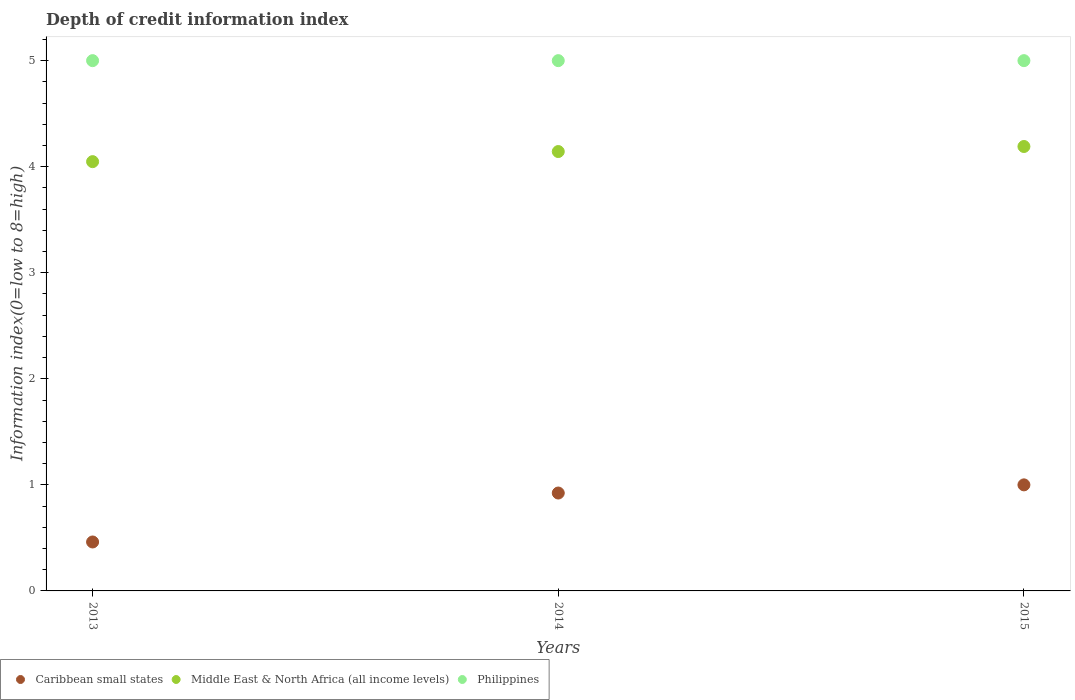Is the number of dotlines equal to the number of legend labels?
Keep it short and to the point. Yes. What is the information index in Philippines in 2014?
Provide a succinct answer. 5. Across all years, what is the maximum information index in Caribbean small states?
Provide a succinct answer. 1. Across all years, what is the minimum information index in Middle East & North Africa (all income levels)?
Ensure brevity in your answer.  4.05. In which year was the information index in Middle East & North Africa (all income levels) maximum?
Provide a short and direct response. 2015. In which year was the information index in Philippines minimum?
Offer a very short reply. 2013. What is the total information index in Middle East & North Africa (all income levels) in the graph?
Provide a short and direct response. 12.38. What is the difference between the information index in Philippines in 2013 and the information index in Middle East & North Africa (all income levels) in 2014?
Offer a very short reply. 0.86. What is the average information index in Middle East & North Africa (all income levels) per year?
Offer a terse response. 4.13. In the year 2014, what is the difference between the information index in Philippines and information index in Caribbean small states?
Give a very brief answer. 4.08. What is the ratio of the information index in Caribbean small states in 2014 to that in 2015?
Offer a very short reply. 0.92. What is the difference between the highest and the second highest information index in Caribbean small states?
Your answer should be very brief. 0.08. What is the difference between the highest and the lowest information index in Middle East & North Africa (all income levels)?
Offer a very short reply. 0.14. In how many years, is the information index in Caribbean small states greater than the average information index in Caribbean small states taken over all years?
Make the answer very short. 2. Is it the case that in every year, the sum of the information index in Philippines and information index in Middle East & North Africa (all income levels)  is greater than the information index in Caribbean small states?
Provide a short and direct response. Yes. What is the difference between two consecutive major ticks on the Y-axis?
Offer a very short reply. 1. Are the values on the major ticks of Y-axis written in scientific E-notation?
Make the answer very short. No. Does the graph contain any zero values?
Your response must be concise. No. Does the graph contain grids?
Offer a terse response. No. What is the title of the graph?
Your answer should be very brief. Depth of credit information index. Does "Cayman Islands" appear as one of the legend labels in the graph?
Your response must be concise. No. What is the label or title of the Y-axis?
Make the answer very short. Information index(0=low to 8=high). What is the Information index(0=low to 8=high) of Caribbean small states in 2013?
Provide a short and direct response. 0.46. What is the Information index(0=low to 8=high) of Middle East & North Africa (all income levels) in 2013?
Ensure brevity in your answer.  4.05. What is the Information index(0=low to 8=high) of Philippines in 2013?
Your response must be concise. 5. What is the Information index(0=low to 8=high) of Caribbean small states in 2014?
Your response must be concise. 0.92. What is the Information index(0=low to 8=high) in Middle East & North Africa (all income levels) in 2014?
Give a very brief answer. 4.14. What is the Information index(0=low to 8=high) in Philippines in 2014?
Your answer should be compact. 5. What is the Information index(0=low to 8=high) in Middle East & North Africa (all income levels) in 2015?
Your response must be concise. 4.19. Across all years, what is the maximum Information index(0=low to 8=high) of Middle East & North Africa (all income levels)?
Your answer should be compact. 4.19. Across all years, what is the minimum Information index(0=low to 8=high) in Caribbean small states?
Provide a short and direct response. 0.46. Across all years, what is the minimum Information index(0=low to 8=high) in Middle East & North Africa (all income levels)?
Your answer should be compact. 4.05. What is the total Information index(0=low to 8=high) in Caribbean small states in the graph?
Keep it short and to the point. 2.38. What is the total Information index(0=low to 8=high) in Middle East & North Africa (all income levels) in the graph?
Keep it short and to the point. 12.38. What is the total Information index(0=low to 8=high) of Philippines in the graph?
Provide a succinct answer. 15. What is the difference between the Information index(0=low to 8=high) of Caribbean small states in 2013 and that in 2014?
Keep it short and to the point. -0.46. What is the difference between the Information index(0=low to 8=high) in Middle East & North Africa (all income levels) in 2013 and that in 2014?
Give a very brief answer. -0.1. What is the difference between the Information index(0=low to 8=high) of Philippines in 2013 and that in 2014?
Ensure brevity in your answer.  0. What is the difference between the Information index(0=low to 8=high) of Caribbean small states in 2013 and that in 2015?
Your answer should be very brief. -0.54. What is the difference between the Information index(0=low to 8=high) in Middle East & North Africa (all income levels) in 2013 and that in 2015?
Provide a succinct answer. -0.14. What is the difference between the Information index(0=low to 8=high) of Caribbean small states in 2014 and that in 2015?
Offer a terse response. -0.08. What is the difference between the Information index(0=low to 8=high) of Middle East & North Africa (all income levels) in 2014 and that in 2015?
Offer a terse response. -0.05. What is the difference between the Information index(0=low to 8=high) of Philippines in 2014 and that in 2015?
Offer a very short reply. 0. What is the difference between the Information index(0=low to 8=high) of Caribbean small states in 2013 and the Information index(0=low to 8=high) of Middle East & North Africa (all income levels) in 2014?
Provide a short and direct response. -3.68. What is the difference between the Information index(0=low to 8=high) of Caribbean small states in 2013 and the Information index(0=low to 8=high) of Philippines in 2014?
Offer a very short reply. -4.54. What is the difference between the Information index(0=low to 8=high) of Middle East & North Africa (all income levels) in 2013 and the Information index(0=low to 8=high) of Philippines in 2014?
Provide a succinct answer. -0.95. What is the difference between the Information index(0=low to 8=high) in Caribbean small states in 2013 and the Information index(0=low to 8=high) in Middle East & North Africa (all income levels) in 2015?
Your answer should be very brief. -3.73. What is the difference between the Information index(0=low to 8=high) of Caribbean small states in 2013 and the Information index(0=low to 8=high) of Philippines in 2015?
Offer a terse response. -4.54. What is the difference between the Information index(0=low to 8=high) in Middle East & North Africa (all income levels) in 2013 and the Information index(0=low to 8=high) in Philippines in 2015?
Ensure brevity in your answer.  -0.95. What is the difference between the Information index(0=low to 8=high) of Caribbean small states in 2014 and the Information index(0=low to 8=high) of Middle East & North Africa (all income levels) in 2015?
Your answer should be very brief. -3.27. What is the difference between the Information index(0=low to 8=high) in Caribbean small states in 2014 and the Information index(0=low to 8=high) in Philippines in 2015?
Provide a short and direct response. -4.08. What is the difference between the Information index(0=low to 8=high) of Middle East & North Africa (all income levels) in 2014 and the Information index(0=low to 8=high) of Philippines in 2015?
Ensure brevity in your answer.  -0.86. What is the average Information index(0=low to 8=high) of Caribbean small states per year?
Make the answer very short. 0.79. What is the average Information index(0=low to 8=high) in Middle East & North Africa (all income levels) per year?
Provide a succinct answer. 4.13. In the year 2013, what is the difference between the Information index(0=low to 8=high) of Caribbean small states and Information index(0=low to 8=high) of Middle East & North Africa (all income levels)?
Offer a very short reply. -3.59. In the year 2013, what is the difference between the Information index(0=low to 8=high) in Caribbean small states and Information index(0=low to 8=high) in Philippines?
Your answer should be very brief. -4.54. In the year 2013, what is the difference between the Information index(0=low to 8=high) of Middle East & North Africa (all income levels) and Information index(0=low to 8=high) of Philippines?
Give a very brief answer. -0.95. In the year 2014, what is the difference between the Information index(0=low to 8=high) in Caribbean small states and Information index(0=low to 8=high) in Middle East & North Africa (all income levels)?
Your answer should be very brief. -3.22. In the year 2014, what is the difference between the Information index(0=low to 8=high) of Caribbean small states and Information index(0=low to 8=high) of Philippines?
Give a very brief answer. -4.08. In the year 2014, what is the difference between the Information index(0=low to 8=high) in Middle East & North Africa (all income levels) and Information index(0=low to 8=high) in Philippines?
Ensure brevity in your answer.  -0.86. In the year 2015, what is the difference between the Information index(0=low to 8=high) of Caribbean small states and Information index(0=low to 8=high) of Middle East & North Africa (all income levels)?
Your answer should be compact. -3.19. In the year 2015, what is the difference between the Information index(0=low to 8=high) of Middle East & North Africa (all income levels) and Information index(0=low to 8=high) of Philippines?
Your response must be concise. -0.81. What is the ratio of the Information index(0=low to 8=high) in Caribbean small states in 2013 to that in 2014?
Ensure brevity in your answer.  0.5. What is the ratio of the Information index(0=low to 8=high) in Middle East & North Africa (all income levels) in 2013 to that in 2014?
Your answer should be compact. 0.98. What is the ratio of the Information index(0=low to 8=high) in Philippines in 2013 to that in 2014?
Offer a terse response. 1. What is the ratio of the Information index(0=low to 8=high) of Caribbean small states in 2013 to that in 2015?
Your response must be concise. 0.46. What is the ratio of the Information index(0=low to 8=high) of Middle East & North Africa (all income levels) in 2013 to that in 2015?
Keep it short and to the point. 0.97. What is the ratio of the Information index(0=low to 8=high) of Caribbean small states in 2014 to that in 2015?
Ensure brevity in your answer.  0.92. What is the difference between the highest and the second highest Information index(0=low to 8=high) in Caribbean small states?
Offer a very short reply. 0.08. What is the difference between the highest and the second highest Information index(0=low to 8=high) of Middle East & North Africa (all income levels)?
Provide a succinct answer. 0.05. What is the difference between the highest and the lowest Information index(0=low to 8=high) in Caribbean small states?
Your response must be concise. 0.54. What is the difference between the highest and the lowest Information index(0=low to 8=high) of Middle East & North Africa (all income levels)?
Make the answer very short. 0.14. 